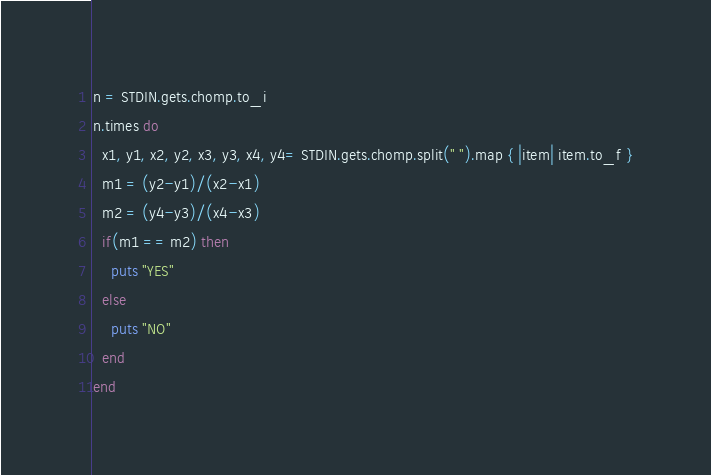Convert code to text. <code><loc_0><loc_0><loc_500><loc_500><_Ruby_>n = STDIN.gets.chomp.to_i
n.times do
  x1, y1, x2, y2, x3, y3, x4, y4= STDIN.gets.chomp.split(" ").map { |item| item.to_f }
  m1 = (y2-y1)/(x2-x1)
  m2 = (y4-y3)/(x4-x3)
  if(m1 == m2) then
    puts "YES"
  else
    puts "NO"
  end
end</code> 